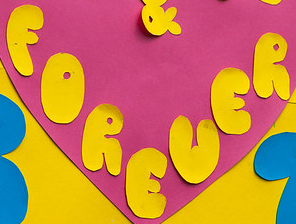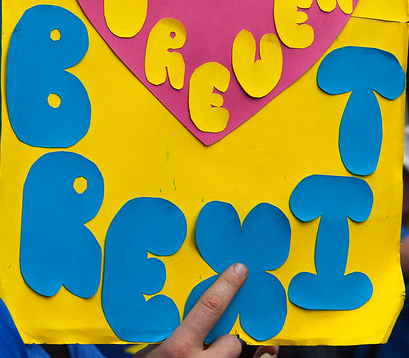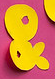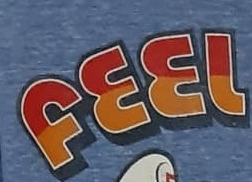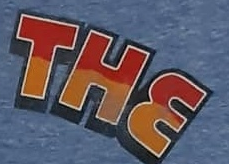Identify the words shown in these images in order, separated by a semicolon. FOREUER; BREXIT; &; FEEL; THE 